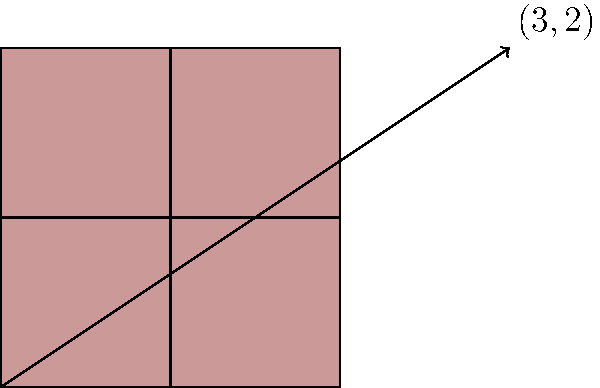As a fashion-forward retail worker, you're designing a repeated pattern for a new fabric line. The base pattern is a square, and you want to translate it to create a larger design. If the translation vector is $(3,2)$, what will be the coordinates of the top-right corner of the translated square if the original square has corners at $(0,0)$, $(1,0)$, $(1,1)$, and $(0,1)$? Let's approach this step-by-step:

1) The original square has its top-right corner at $(1,1)$.

2) The translation vector is $(3,2)$. This means we need to add 3 to the x-coordinate and 2 to the y-coordinate of every point in the original square.

3) To find the new coordinates of the top-right corner:
   - Original x-coordinate: 1
   - Translation in x-direction: 3
   - New x-coordinate: $1 + 3 = 4$

   - Original y-coordinate: 1
   - Translation in y-direction: 2
   - New y-coordinate: $1 + 2 = 3$

4) Therefore, the coordinates of the top-right corner of the translated square will be $(4,3)$.

This translation can be represented mathematically as:

$$(x,y) \rightarrow (x+3, y+2)$$

where $(x,y)$ are the coordinates of any point in the original square.
Answer: $(4,3)$ 